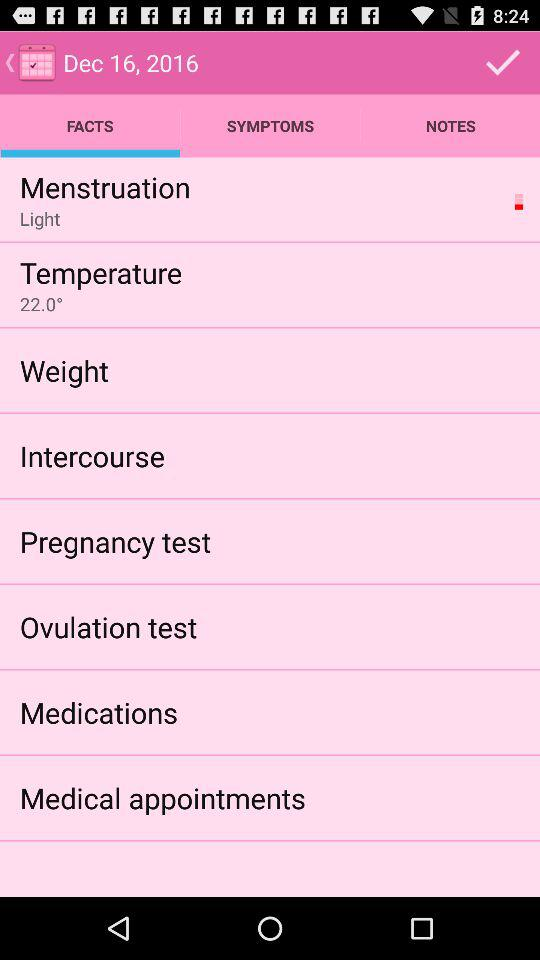What tab am I on? You are on the Facts tab. 